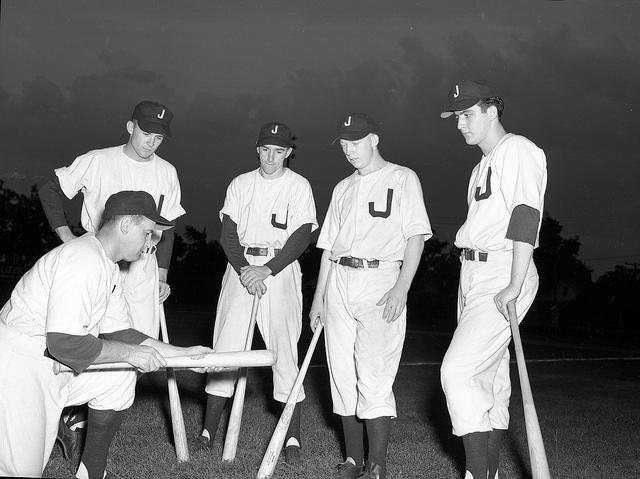How many people are in the picture?
Give a very brief answer. 5. How many baseball bats are in the picture?
Give a very brief answer. 2. How many people are visible?
Give a very brief answer. 5. 